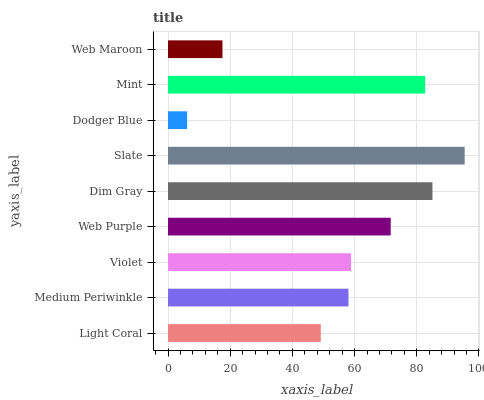Is Dodger Blue the minimum?
Answer yes or no. Yes. Is Slate the maximum?
Answer yes or no. Yes. Is Medium Periwinkle the minimum?
Answer yes or no. No. Is Medium Periwinkle the maximum?
Answer yes or no. No. Is Medium Periwinkle greater than Light Coral?
Answer yes or no. Yes. Is Light Coral less than Medium Periwinkle?
Answer yes or no. Yes. Is Light Coral greater than Medium Periwinkle?
Answer yes or no. No. Is Medium Periwinkle less than Light Coral?
Answer yes or no. No. Is Violet the high median?
Answer yes or no. Yes. Is Violet the low median?
Answer yes or no. Yes. Is Light Coral the high median?
Answer yes or no. No. Is Dodger Blue the low median?
Answer yes or no. No. 